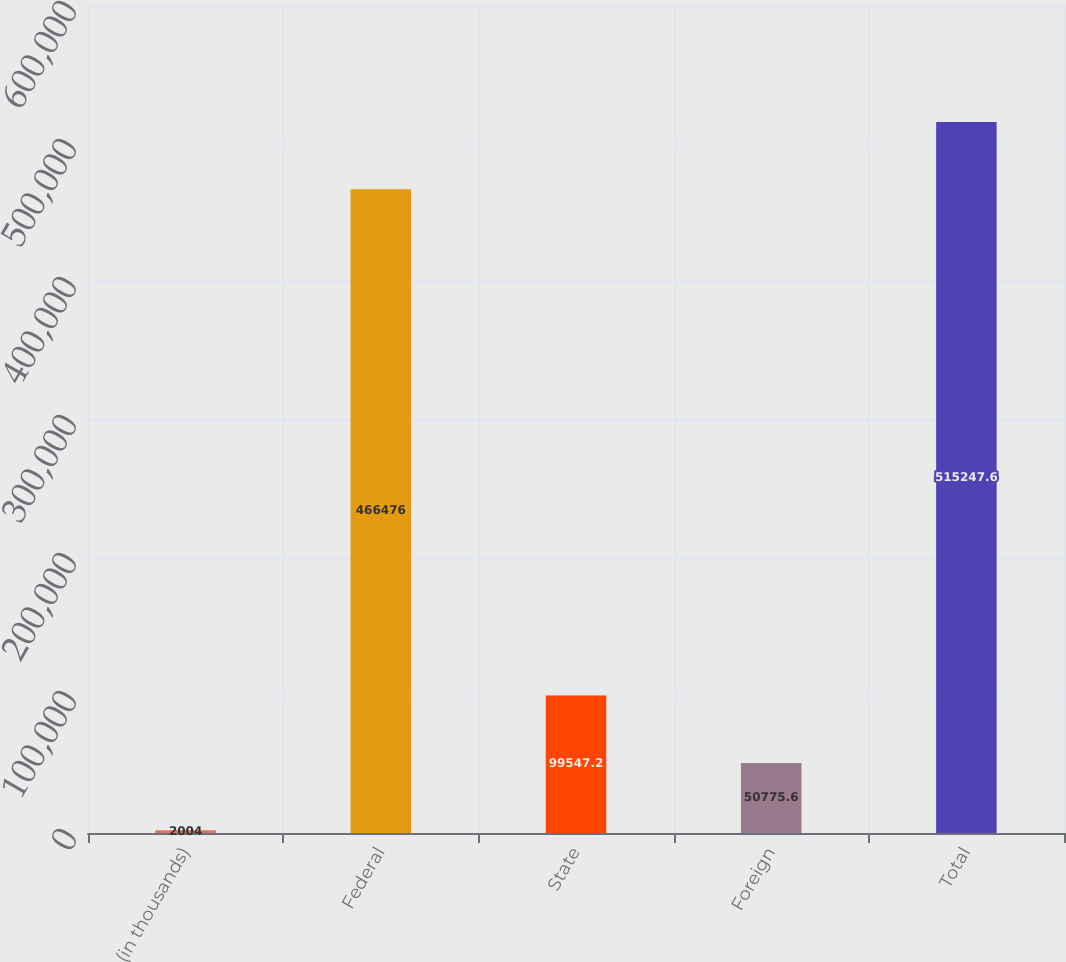<chart> <loc_0><loc_0><loc_500><loc_500><bar_chart><fcel>(in thousands)<fcel>Federal<fcel>State<fcel>Foreign<fcel>Total<nl><fcel>2004<fcel>466476<fcel>99547.2<fcel>50775.6<fcel>515248<nl></chart> 